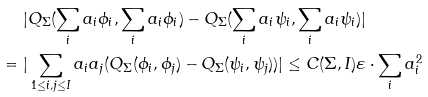<formula> <loc_0><loc_0><loc_500><loc_500>& | Q _ { \Sigma } ( \sum _ { i } a _ { i } \phi _ { i } , \sum _ { i } a _ { i } \phi _ { i } ) - Q _ { \Sigma } ( \sum _ { i } a _ { i } \psi _ { i } , \sum _ { i } a _ { i } \psi _ { i } ) | \\ = \ & | \sum _ { 1 \leq i , j \leq I } a _ { i } a _ { j } ( Q _ { \Sigma } ( \phi _ { i } , \phi _ { j } ) - Q _ { \Sigma } ( \psi _ { i } , \psi _ { j } ) ) | \leq C ( \Sigma , I ) \varepsilon \cdot \sum _ { i } a _ { i } ^ { 2 }</formula> 